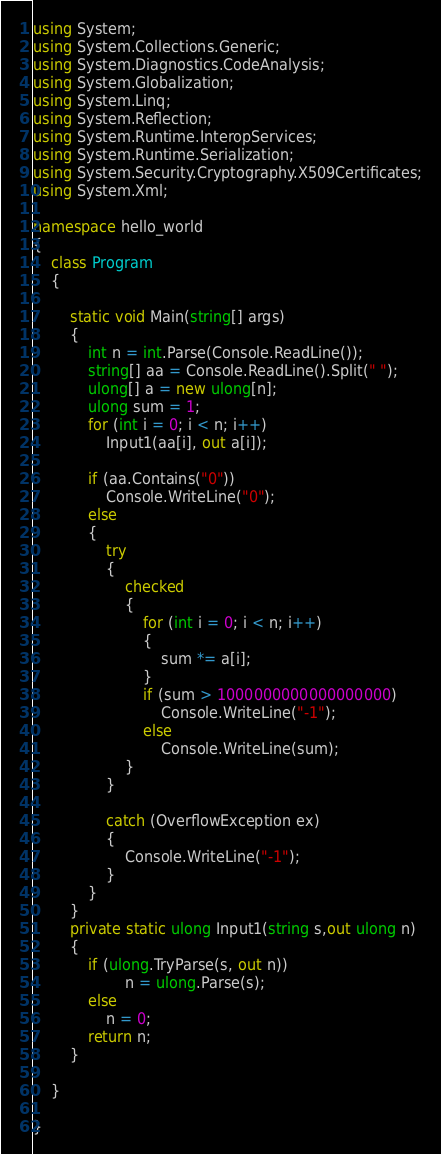<code> <loc_0><loc_0><loc_500><loc_500><_C#_>using System;
using System.Collections.Generic;
using System.Diagnostics.CodeAnalysis;
using System.Globalization;
using System.Linq;
using System.Reflection;
using System.Runtime.InteropServices;
using System.Runtime.Serialization;
using System.Security.Cryptography.X509Certificates;
using System.Xml;

namespace hello_world
{
	class Program
	{

		static void Main(string[] args)
		{
			int n = int.Parse(Console.ReadLine());
			string[] aa = Console.ReadLine().Split(" ");
			ulong[] a = new ulong[n];
			ulong sum = 1;
			for (int i = 0; i < n; i++)
				Input1(aa[i], out a[i]); 

			if (aa.Contains("0"))
				Console.WriteLine("0");
			else
			{
				try
				{
					checked
					{
						for (int i = 0; i < n; i++)
						{
							sum *= a[i];
						}
						if (sum > 1000000000000000000)
							Console.WriteLine("-1");
						else
							Console.WriteLine(sum);
					}
				}

				catch (OverflowException ex)
				{
					Console.WriteLine("-1");
				}
			}
		}
		private static ulong Input1(string s,out ulong n) 
		{
			if (ulong.TryParse(s, out n))
					n = ulong.Parse(s);
			else
				n = 0;
			return n; 
		}
		
	}
	 
}


</code> 